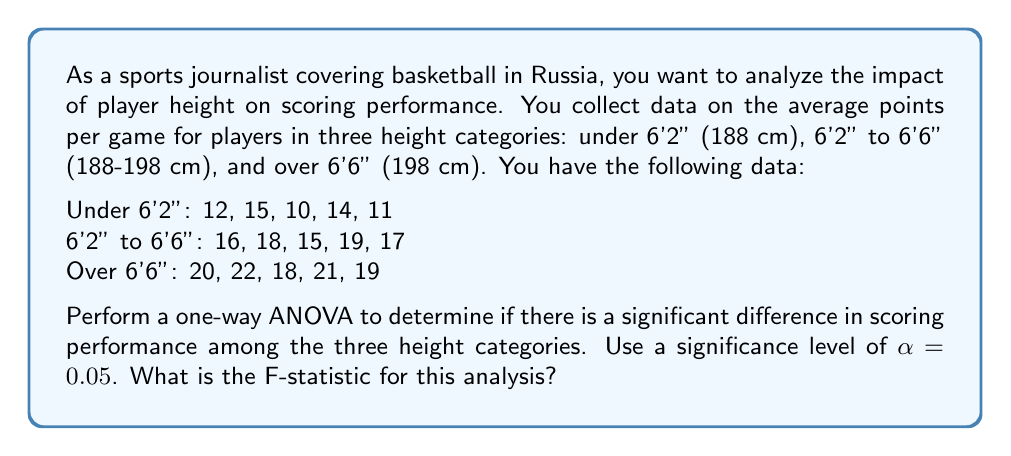What is the answer to this math problem? To perform a one-way ANOVA, we need to follow these steps:

1. Calculate the sum of squares between groups (SSB)
2. Calculate the sum of squares within groups (SSW)
3. Calculate the total sum of squares (SST)
4. Calculate the degrees of freedom
5. Calculate the mean squares
6. Calculate the F-statistic

Step 1: Calculate SSB

First, we need to find the grand mean and group means:

Grand mean: $\bar{X} = \frac{12+15+10+14+11+16+18+15+19+17+20+22+18+21+19}{15} = 16.47$

Group means:
$\bar{X}_1 = 12.4$ (Under 6'2")
$\bar{X}_2 = 17$ (6'2" to 6'6")
$\bar{X}_3 = 20$ (Over 6'6")

Now, we can calculate SSB:

$$SSB = \sum_{i=1}^{k} n_i(\bar{X}_i - \bar{X})^2$$

Where $k$ is the number of groups and $n_i$ is the number of observations in each group.

$$SSB = 5(12.4 - 16.47)^2 + 5(17 - 16.47)^2 + 5(20 - 16.47)^2 = 161.53$$

Step 2: Calculate SSW

$$SSW = \sum_{i=1}^{k} \sum_{j=1}^{n_i} (X_{ij} - \bar{X}_i)^2$$

Under 6'2": $(12-12.4)^2 + (15-12.4)^2 + (10-12.4)^2 + (14-12.4)^2 + (11-12.4)^2 = 20.8$
6'2" to 6'6": $(16-17)^2 + (18-17)^2 + (15-17)^2 + (19-17)^2 + (17-17)^2 = 12$
Over 6'6": $(20-20)^2 + (22-20)^2 + (18-20)^2 + (21-20)^2 + (19-20)^2 = 12$

$$SSW = 20.8 + 12 + 12 = 44.8$$

Step 3: Calculate SST

$$SST = SSB + SSW = 161.53 + 44.8 = 206.33$$

Step 4: Calculate degrees of freedom

Between groups: $df_B = k - 1 = 3 - 1 = 2$
Within groups: $df_W = N - k = 15 - 3 = 12$
Total: $df_T = N - 1 = 15 - 1 = 14$

Step 5: Calculate mean squares

$$MSB = \frac{SSB}{df_B} = \frac{161.53}{2} = 80.765$$
$$MSW = \frac{SSW}{df_W} = \frac{44.8}{12} = 3.733$$

Step 6: Calculate F-statistic

$$F = \frac{MSB}{MSW} = \frac{80.765}{3.733} = 21.63$$

Therefore, the F-statistic for this analysis is 21.63.
Answer: The F-statistic for this one-way ANOVA analysis is 21.63. 